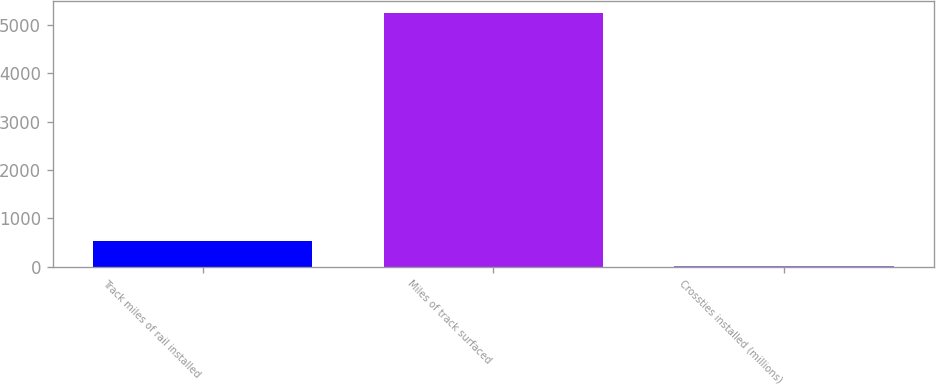<chart> <loc_0><loc_0><loc_500><loc_500><bar_chart><fcel>Track miles of rail installed<fcel>Miles of track surfaced<fcel>Crossties installed (millions)<nl><fcel>527.23<fcel>5248<fcel>2.7<nl></chart> 